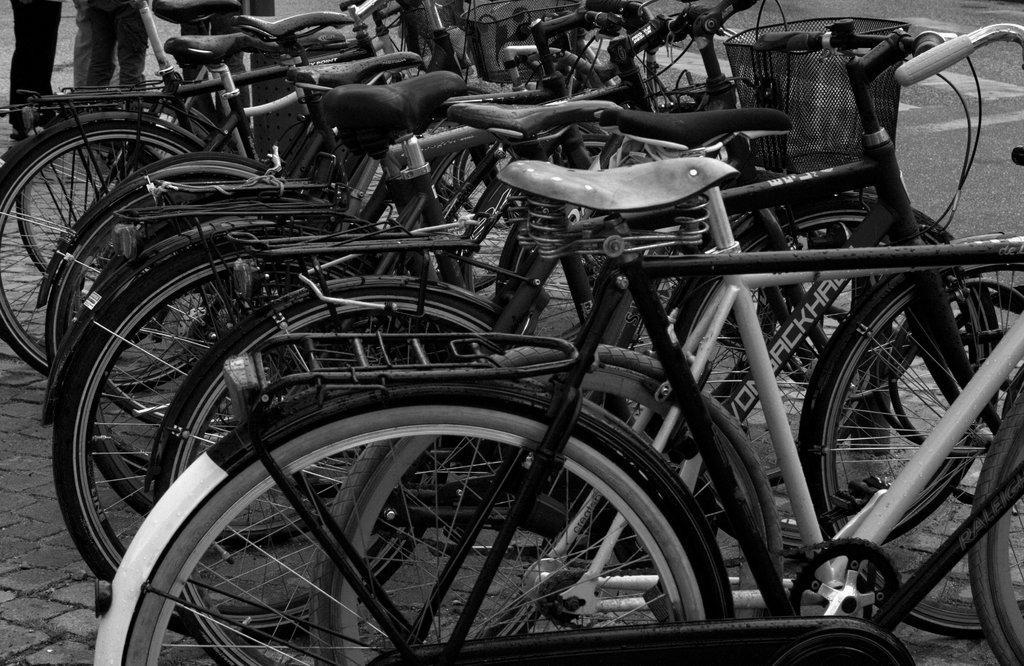Describe this image in one or two sentences. In this picture we can see few bicycles and legs of few persons, it is a black and white photography. 